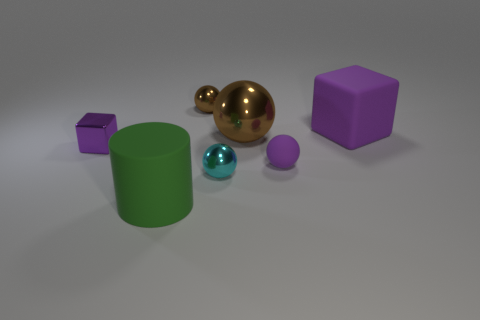Is there any other thing that has the same size as the purple shiny cube?
Your response must be concise. Yes. What number of cylinders are either big objects or small cyan objects?
Keep it short and to the point. 1. What number of tiny shiny objects are both in front of the large purple object and behind the small purple metallic cube?
Make the answer very short. 0. There is a purple metallic cube; does it have the same size as the purple matte sphere that is on the right side of the small block?
Your answer should be very brief. Yes. Are there any small purple things on the right side of the small shiny block to the left of the tiny shiny sphere in front of the large brown metallic sphere?
Provide a short and direct response. Yes. What material is the big thing left of the ball in front of the purple ball made of?
Your answer should be very brief. Rubber. What is the purple thing that is to the right of the rubber cylinder and in front of the large brown metallic sphere made of?
Provide a succinct answer. Rubber. Are there any big gray objects of the same shape as the tiny brown metallic thing?
Provide a short and direct response. No. There is a rubber object that is on the left side of the cyan ball; are there any brown shiny spheres behind it?
Make the answer very short. Yes. How many things have the same material as the large green cylinder?
Your response must be concise. 2. 